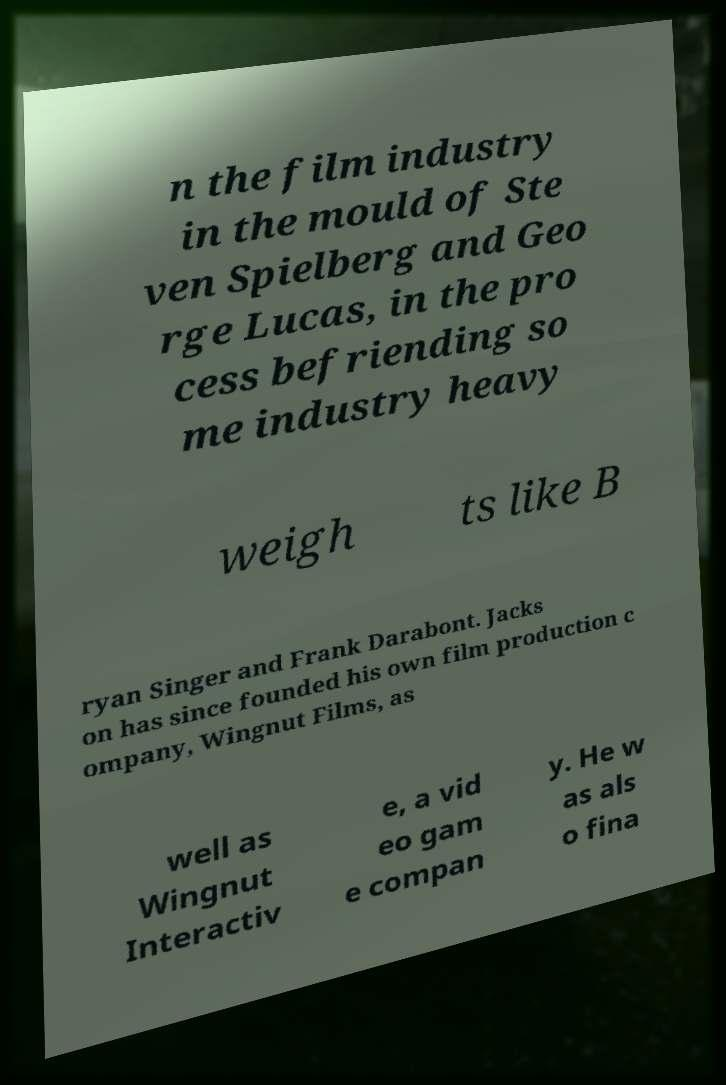Can you accurately transcribe the text from the provided image for me? n the film industry in the mould of Ste ven Spielberg and Geo rge Lucas, in the pro cess befriending so me industry heavy weigh ts like B ryan Singer and Frank Darabont. Jacks on has since founded his own film production c ompany, Wingnut Films, as well as Wingnut Interactiv e, a vid eo gam e compan y. He w as als o fina 